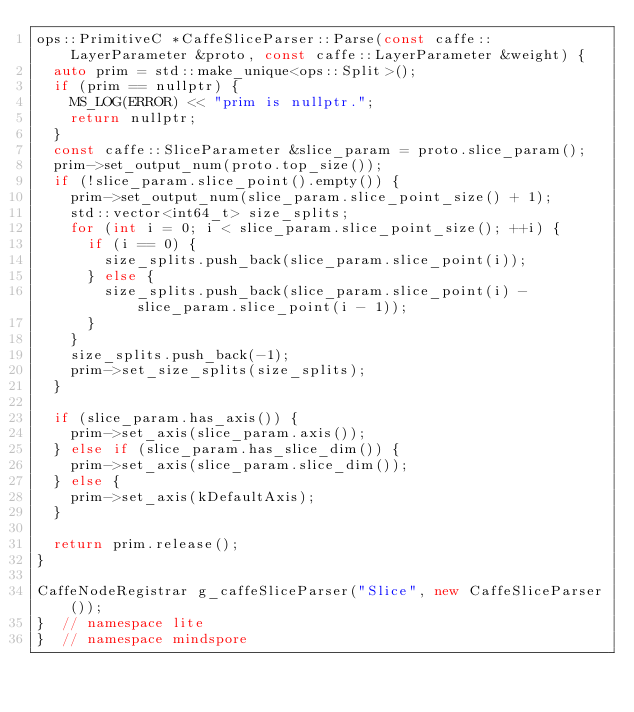Convert code to text. <code><loc_0><loc_0><loc_500><loc_500><_C++_>ops::PrimitiveC *CaffeSliceParser::Parse(const caffe::LayerParameter &proto, const caffe::LayerParameter &weight) {
  auto prim = std::make_unique<ops::Split>();
  if (prim == nullptr) {
    MS_LOG(ERROR) << "prim is nullptr.";
    return nullptr;
  }
  const caffe::SliceParameter &slice_param = proto.slice_param();
  prim->set_output_num(proto.top_size());
  if (!slice_param.slice_point().empty()) {
    prim->set_output_num(slice_param.slice_point_size() + 1);
    std::vector<int64_t> size_splits;
    for (int i = 0; i < slice_param.slice_point_size(); ++i) {
      if (i == 0) {
        size_splits.push_back(slice_param.slice_point(i));
      } else {
        size_splits.push_back(slice_param.slice_point(i) - slice_param.slice_point(i - 1));
      }
    }
    size_splits.push_back(-1);
    prim->set_size_splits(size_splits);
  }

  if (slice_param.has_axis()) {
    prim->set_axis(slice_param.axis());
  } else if (slice_param.has_slice_dim()) {
    prim->set_axis(slice_param.slice_dim());
  } else {
    prim->set_axis(kDefaultAxis);
  }

  return prim.release();
}

CaffeNodeRegistrar g_caffeSliceParser("Slice", new CaffeSliceParser());
}  // namespace lite
}  // namespace mindspore
</code> 